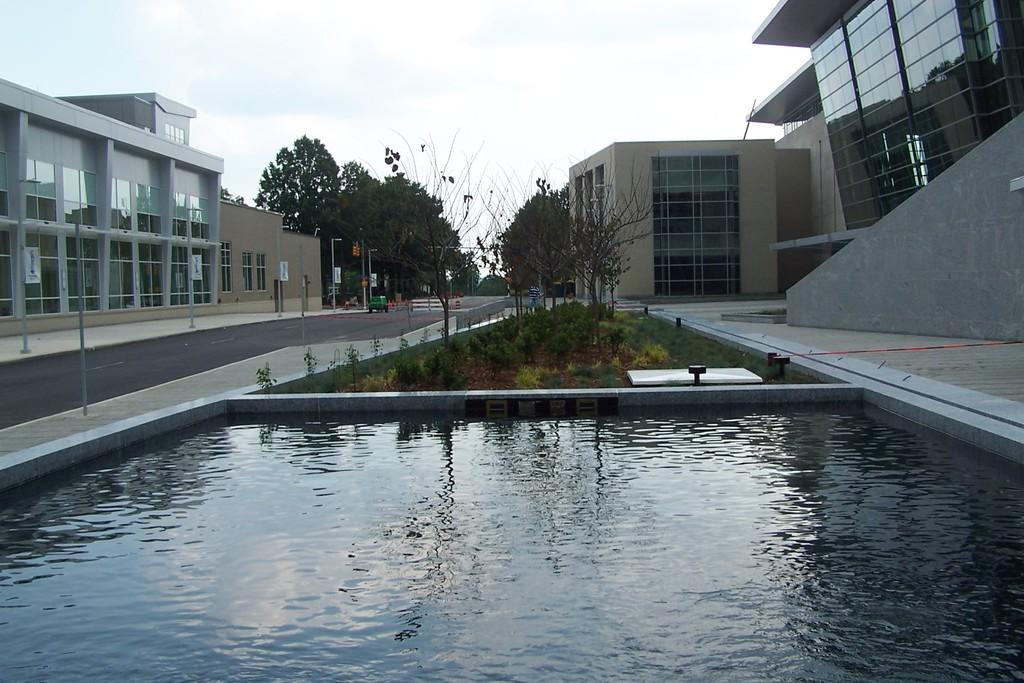What type of body of water is present in the image? There is a pond in the image. What can be seen between the buildings in the image? There are plants between the buildings in the image. What type of vegetation is in the middle of the image? There are trees in the middle of the image. What is visible at the top of the image? The sky is visible at the top of the image. How many girls are on the ship in the image? There is no ship or girls present in the image. What type of view can be seen from the ship in the image? There is no ship or view from a ship in the image. 